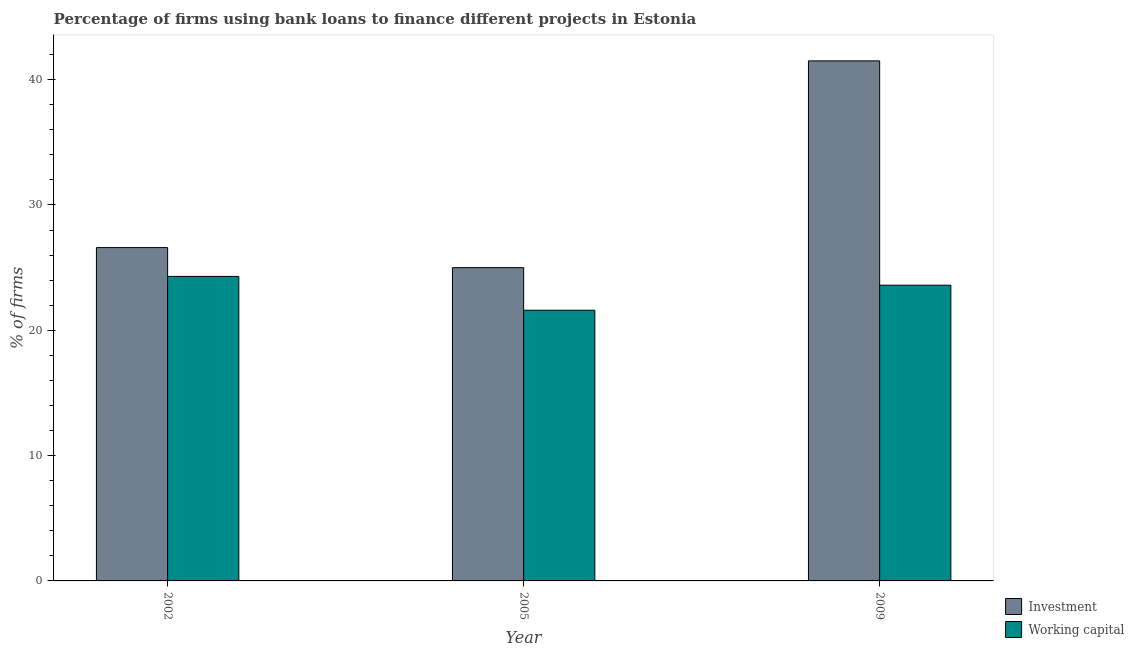How many different coloured bars are there?
Offer a terse response. 2. Are the number of bars per tick equal to the number of legend labels?
Give a very brief answer. Yes. How many bars are there on the 1st tick from the left?
Your answer should be very brief. 2. What is the label of the 3rd group of bars from the left?
Offer a very short reply. 2009. Across all years, what is the maximum percentage of firms using banks to finance investment?
Offer a very short reply. 41.5. What is the total percentage of firms using banks to finance investment in the graph?
Provide a short and direct response. 93.1. What is the difference between the percentage of firms using banks to finance working capital in 2002 and that in 2005?
Your answer should be very brief. 2.7. What is the difference between the percentage of firms using banks to finance investment in 2009 and the percentage of firms using banks to finance working capital in 2002?
Provide a succinct answer. 14.9. What is the average percentage of firms using banks to finance working capital per year?
Offer a very short reply. 23.17. In the year 2009, what is the difference between the percentage of firms using banks to finance working capital and percentage of firms using banks to finance investment?
Provide a short and direct response. 0. In how many years, is the percentage of firms using banks to finance investment greater than 20 %?
Provide a succinct answer. 3. What is the ratio of the percentage of firms using banks to finance working capital in 2002 to that in 2009?
Provide a short and direct response. 1.03. Is the percentage of firms using banks to finance working capital in 2002 less than that in 2009?
Offer a very short reply. No. Is the difference between the percentage of firms using banks to finance investment in 2005 and 2009 greater than the difference between the percentage of firms using banks to finance working capital in 2005 and 2009?
Give a very brief answer. No. What is the difference between the highest and the second highest percentage of firms using banks to finance working capital?
Provide a short and direct response. 0.7. What is the difference between the highest and the lowest percentage of firms using banks to finance working capital?
Offer a terse response. 2.7. In how many years, is the percentage of firms using banks to finance investment greater than the average percentage of firms using banks to finance investment taken over all years?
Your answer should be compact. 1. Is the sum of the percentage of firms using banks to finance working capital in 2005 and 2009 greater than the maximum percentage of firms using banks to finance investment across all years?
Make the answer very short. Yes. What does the 2nd bar from the left in 2005 represents?
Your answer should be compact. Working capital. What does the 1st bar from the right in 2005 represents?
Your response must be concise. Working capital. How many years are there in the graph?
Give a very brief answer. 3. Does the graph contain any zero values?
Keep it short and to the point. No. How are the legend labels stacked?
Keep it short and to the point. Vertical. What is the title of the graph?
Provide a succinct answer. Percentage of firms using bank loans to finance different projects in Estonia. What is the label or title of the X-axis?
Your answer should be very brief. Year. What is the label or title of the Y-axis?
Your response must be concise. % of firms. What is the % of firms of Investment in 2002?
Your answer should be compact. 26.6. What is the % of firms in Working capital in 2002?
Your response must be concise. 24.3. What is the % of firms in Investment in 2005?
Give a very brief answer. 25. What is the % of firms in Working capital in 2005?
Make the answer very short. 21.6. What is the % of firms of Investment in 2009?
Your answer should be compact. 41.5. What is the % of firms in Working capital in 2009?
Provide a succinct answer. 23.6. Across all years, what is the maximum % of firms of Investment?
Offer a terse response. 41.5. Across all years, what is the maximum % of firms of Working capital?
Provide a succinct answer. 24.3. Across all years, what is the minimum % of firms of Working capital?
Provide a short and direct response. 21.6. What is the total % of firms in Investment in the graph?
Make the answer very short. 93.1. What is the total % of firms of Working capital in the graph?
Offer a terse response. 69.5. What is the difference between the % of firms of Investment in 2002 and that in 2009?
Your answer should be very brief. -14.9. What is the difference between the % of firms of Investment in 2005 and that in 2009?
Your response must be concise. -16.5. What is the difference between the % of firms of Working capital in 2005 and that in 2009?
Provide a succinct answer. -2. What is the difference between the % of firms in Investment in 2002 and the % of firms in Working capital in 2005?
Offer a terse response. 5. What is the difference between the % of firms in Investment in 2005 and the % of firms in Working capital in 2009?
Make the answer very short. 1.4. What is the average % of firms in Investment per year?
Ensure brevity in your answer.  31.03. What is the average % of firms of Working capital per year?
Ensure brevity in your answer.  23.17. In the year 2002, what is the difference between the % of firms of Investment and % of firms of Working capital?
Provide a succinct answer. 2.3. What is the ratio of the % of firms in Investment in 2002 to that in 2005?
Keep it short and to the point. 1.06. What is the ratio of the % of firms of Working capital in 2002 to that in 2005?
Your response must be concise. 1.12. What is the ratio of the % of firms in Investment in 2002 to that in 2009?
Offer a very short reply. 0.64. What is the ratio of the % of firms in Working capital in 2002 to that in 2009?
Give a very brief answer. 1.03. What is the ratio of the % of firms in Investment in 2005 to that in 2009?
Keep it short and to the point. 0.6. What is the ratio of the % of firms in Working capital in 2005 to that in 2009?
Offer a very short reply. 0.92. What is the difference between the highest and the second highest % of firms in Working capital?
Ensure brevity in your answer.  0.7. 